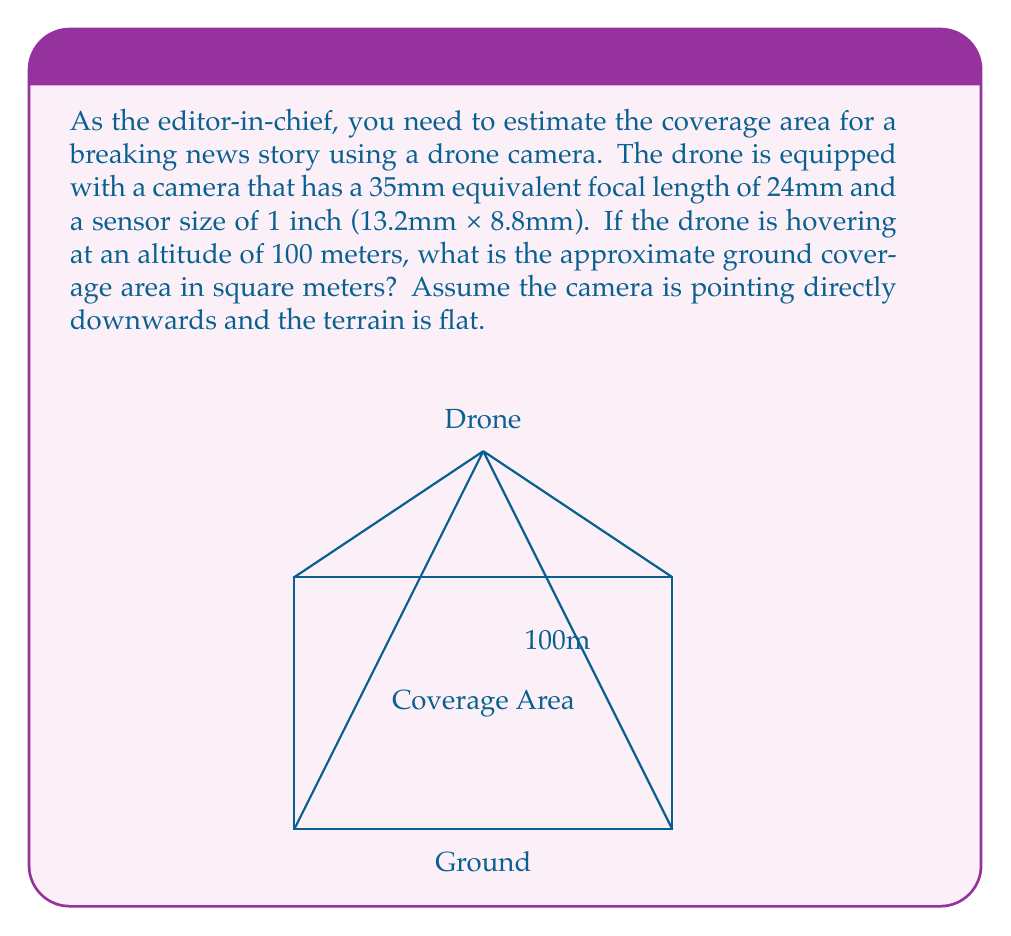Can you solve this math problem? To solve this problem, we'll use the concept of field of view (FOV) and some trigonometry. Let's break it down step-by-step:

1) First, we need to calculate the horizontal and vertical field of view angles:

   Horizontal FOV = 2 * arctan(sensor width / (2 * focal length))
   $$ \text{HFOV} = 2 \cdot \arctan\left(\frac{13.2}{2 \cdot 24}\right) \approx 0.5411 \text{ radians} \approx 31.0^\circ $$

   Vertical FOV = 2 * arctan(sensor height / (2 * focal length))
   $$ \text{VFOV} = 2 \cdot \arctan\left(\frac{8.8}{2 \cdot 24}\right) \approx 0.3644 \text{ radians} \approx 20.9^\circ $$

2) Now, we can calculate the width and height of the coverage area using the altitude and FOV angles:

   Width = 2 * altitude * tan(HFOV/2)
   $$ \text{Width} = 2 \cdot 100 \cdot \tan(0.5411/2) \approx 54.92 \text{ meters} $$

   Height = 2 * altitude * tan(VFOV/2)
   $$ \text{Height} = 2 \cdot 100 \cdot \tan(0.3644/2) \approx 36.61 \text{ meters} $$

3) Finally, we can calculate the coverage area by multiplying the width and height:

   Coverage Area = Width * Height
   $$ \text{Area} = 54.92 \cdot 36.61 \approx 2010.61 \text{ square meters} $$

Therefore, the approximate ground coverage area is about 2010.61 square meters.
Answer: $$2010.61 \text{ m}^2$$ 